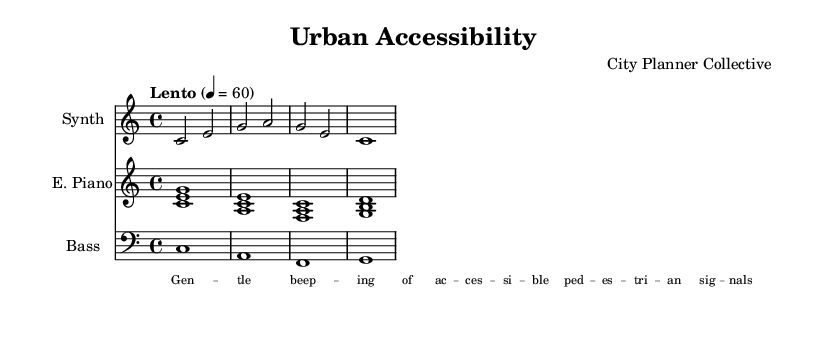What is the key signature of this music? The key signature is indicated at the beginning of the staff with a C major designation, which has no sharps or flats.
Answer: C major What is the time signature of this piece? The time signature is shown as a 4/4 at the beginning, meaning there are four beats in each measure.
Answer: 4/4 What is the tempo marking listed in the score? The tempo marking indicates "Lento" and a specific metronome marking of 60 beats per minute, suggesting a slow pace.
Answer: Lento, 60 How many measures are present in the synthesizer part? By counting the measures within the staff for the synthesizer, there are four measures total, each marked by vertical lines.
Answer: 4 What is the duration of the longest note in the electric piano part? The electric piano part has all its notes as whole notes, identified by the notation, thus the longest note duration is a whole note.
Answer: Whole note What instrumental roles are indicated in this composition? The score mentions three instrumental roles specified at the beginning of each staff: Synth, E. Piano, and Bass, each unique in their contributions.
Answer: Synth, E. Piano, Bass What is the nature of the lyrics associated with the field recordings? The lyrics discuss the gentle beeping of accessible pedestrian signals, highlighting an aspect of urban accessibility in the composition.
Answer: Gentle beeping of accessible pedestrian signals 